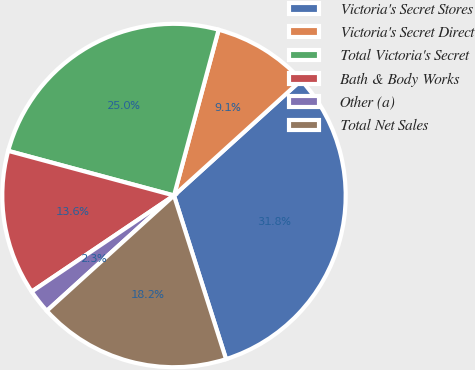Convert chart to OTSL. <chart><loc_0><loc_0><loc_500><loc_500><pie_chart><fcel>Victoria's Secret Stores<fcel>Victoria's Secret Direct<fcel>Total Victoria's Secret<fcel>Bath & Body Works<fcel>Other (a)<fcel>Total Net Sales<nl><fcel>31.82%<fcel>9.09%<fcel>25.0%<fcel>13.64%<fcel>2.27%<fcel>18.18%<nl></chart> 